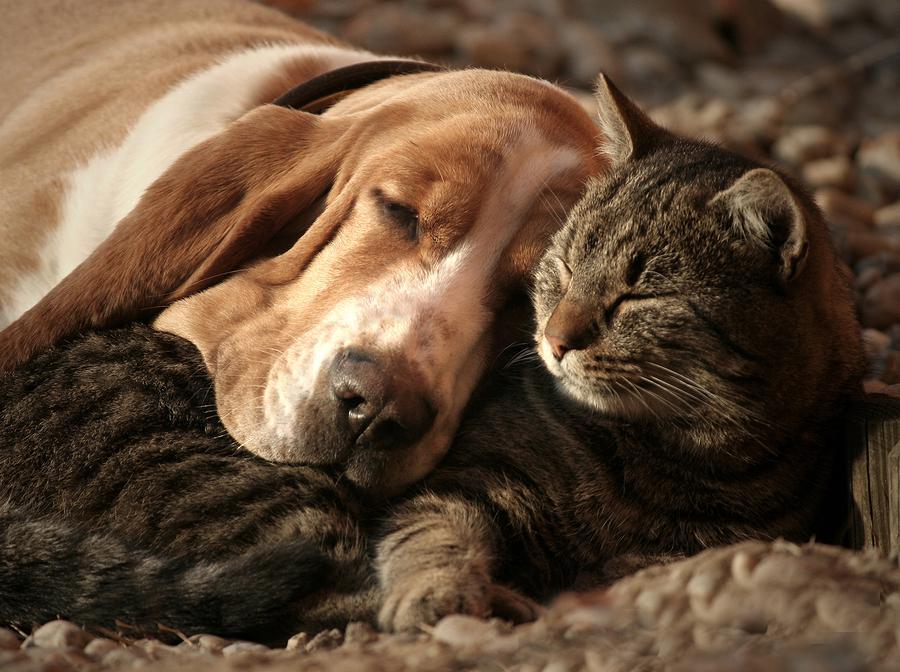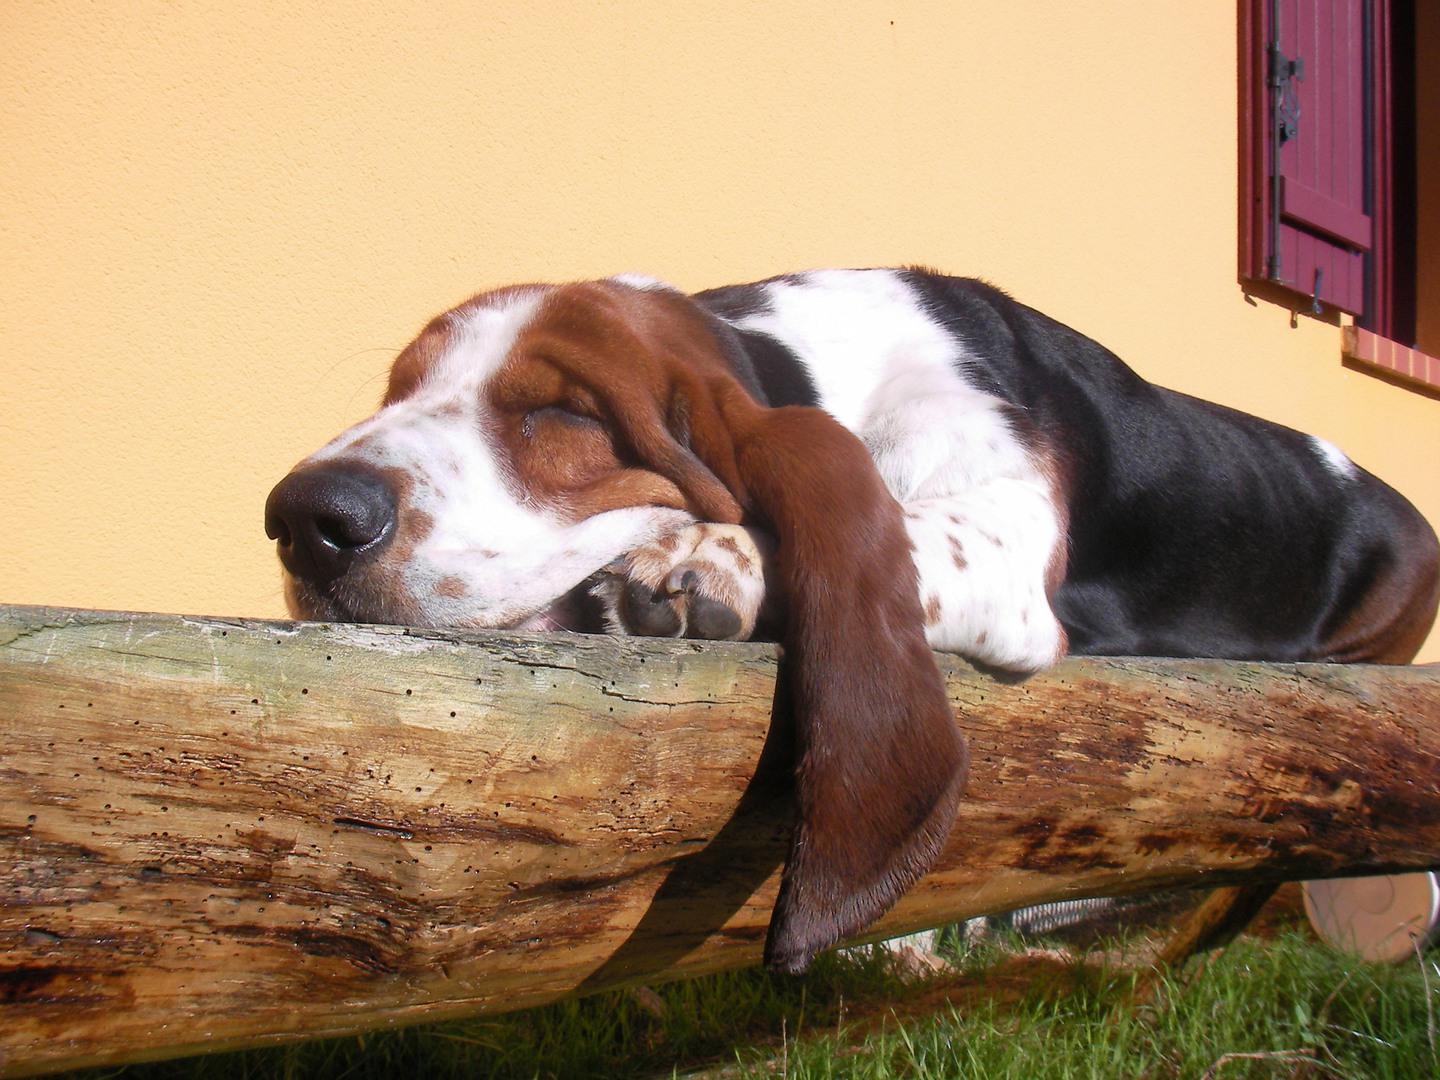The first image is the image on the left, the second image is the image on the right. For the images displayed, is the sentence "a dog has his head on a pillow" factually correct? Answer yes or no. No. The first image is the image on the left, the second image is the image on the right. Given the left and right images, does the statement "At least one dog is cuddling with a furry friend." hold true? Answer yes or no. Yes. 